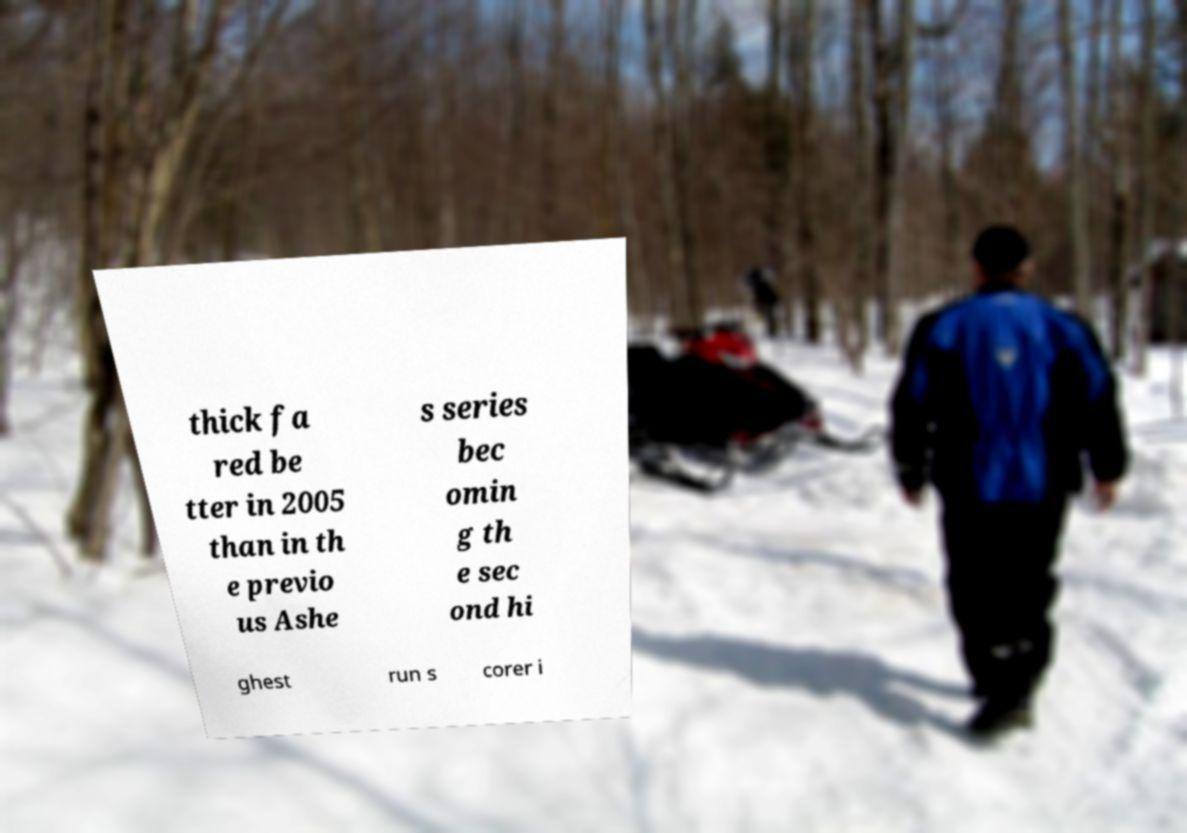For documentation purposes, I need the text within this image transcribed. Could you provide that? thick fa red be tter in 2005 than in th e previo us Ashe s series bec omin g th e sec ond hi ghest run s corer i 